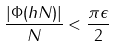Convert formula to latex. <formula><loc_0><loc_0><loc_500><loc_500>\frac { | \Phi ( h N ) | } { N } < \frac { \pi \epsilon } { 2 }</formula> 